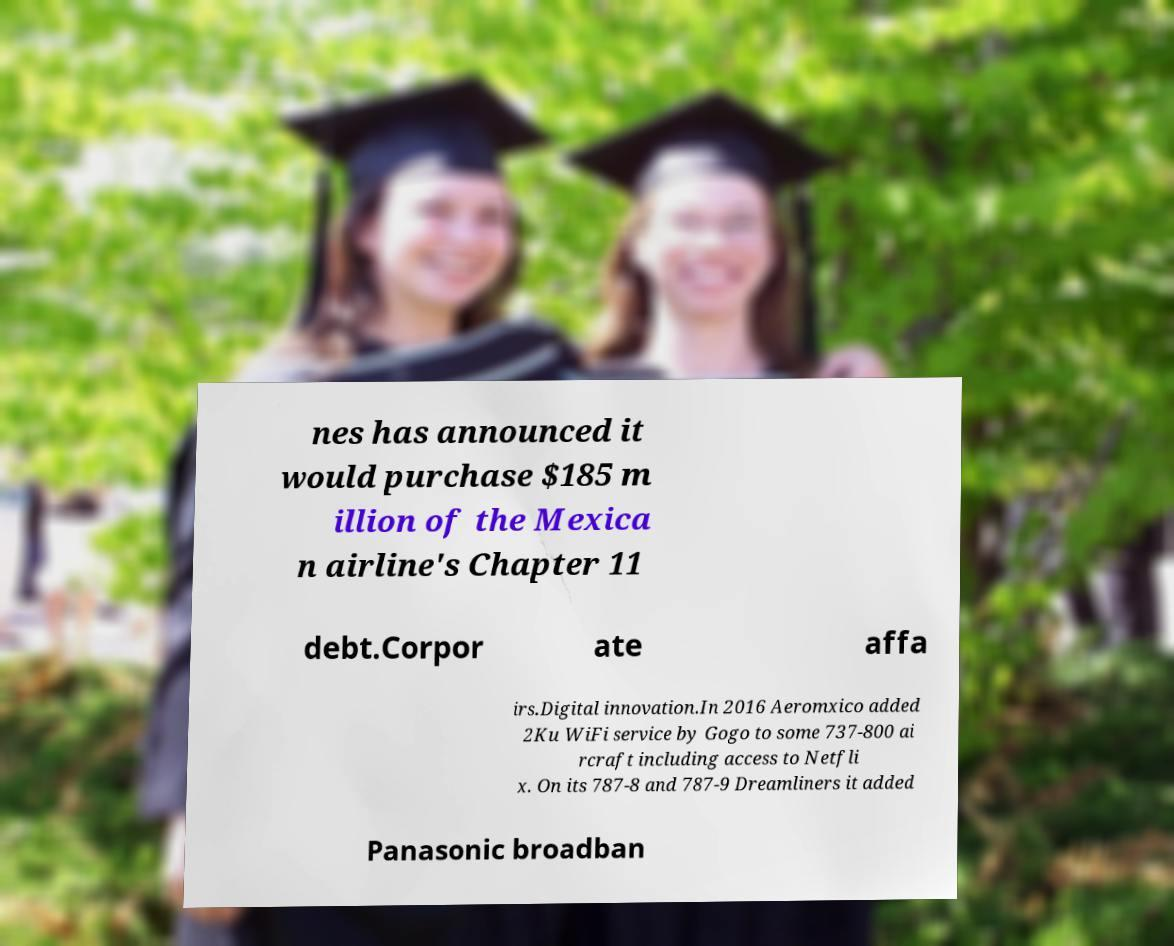Can you read and provide the text displayed in the image?This photo seems to have some interesting text. Can you extract and type it out for me? nes has announced it would purchase $185 m illion of the Mexica n airline's Chapter 11 debt.Corpor ate affa irs.Digital innovation.In 2016 Aeromxico added 2Ku WiFi service by Gogo to some 737-800 ai rcraft including access to Netfli x. On its 787-8 and 787-9 Dreamliners it added Panasonic broadban 